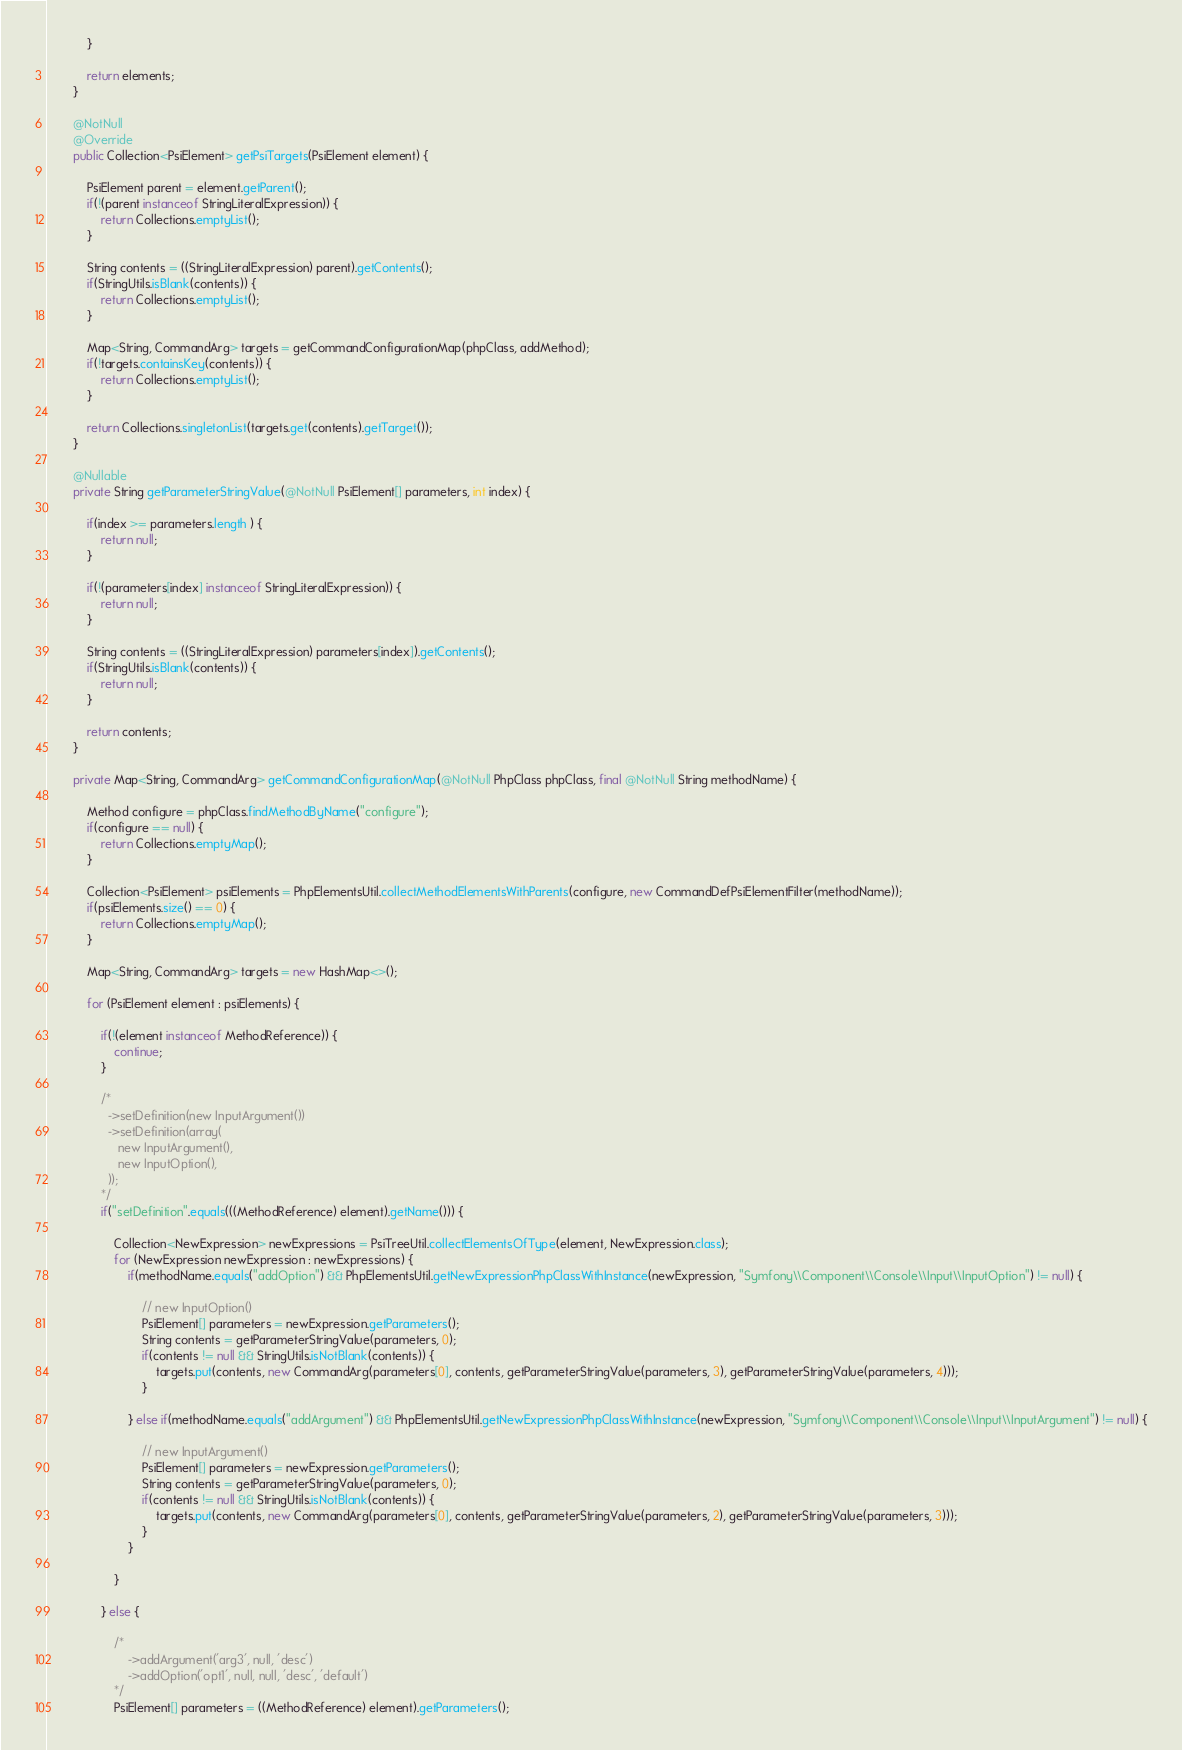<code> <loc_0><loc_0><loc_500><loc_500><_Java_>            }

            return elements;
        }

        @NotNull
        @Override
        public Collection<PsiElement> getPsiTargets(PsiElement element) {

            PsiElement parent = element.getParent();
            if(!(parent instanceof StringLiteralExpression)) {
                return Collections.emptyList();
            }

            String contents = ((StringLiteralExpression) parent).getContents();
            if(StringUtils.isBlank(contents)) {
                return Collections.emptyList();
            }

            Map<String, CommandArg> targets = getCommandConfigurationMap(phpClass, addMethod);
            if(!targets.containsKey(contents)) {
                return Collections.emptyList();
            }

            return Collections.singletonList(targets.get(contents).getTarget());
        }

        @Nullable
        private String getParameterStringValue(@NotNull PsiElement[] parameters, int index) {

            if(index >= parameters.length ) {
                return null;
            }

            if(!(parameters[index] instanceof StringLiteralExpression)) {
                return null;
            }

            String contents = ((StringLiteralExpression) parameters[index]).getContents();
            if(StringUtils.isBlank(contents)) {
                return null;
            }

            return contents;
        }

        private Map<String, CommandArg> getCommandConfigurationMap(@NotNull PhpClass phpClass, final @NotNull String methodName) {

            Method configure = phpClass.findMethodByName("configure");
            if(configure == null) {
                return Collections.emptyMap();
            }

            Collection<PsiElement> psiElements = PhpElementsUtil.collectMethodElementsWithParents(configure, new CommandDefPsiElementFilter(methodName));
            if(psiElements.size() == 0) {
                return Collections.emptyMap();
            }

            Map<String, CommandArg> targets = new HashMap<>();

            for (PsiElement element : psiElements) {

                if(!(element instanceof MethodReference)) {
                    continue;
                }

                /*
                  ->setDefinition(new InputArgument())
                  ->setDefinition(array(
                     new InputArgument(),
                     new InputOption(),
                  ));
                */
                if("setDefinition".equals(((MethodReference) element).getName())) {

                    Collection<NewExpression> newExpressions = PsiTreeUtil.collectElementsOfType(element, NewExpression.class);
                    for (NewExpression newExpression : newExpressions) {
                        if(methodName.equals("addOption") && PhpElementsUtil.getNewExpressionPhpClassWithInstance(newExpression, "Symfony\\Component\\Console\\Input\\InputOption") != null) {

                            // new InputOption()
                            PsiElement[] parameters = newExpression.getParameters();
                            String contents = getParameterStringValue(parameters, 0);
                            if(contents != null && StringUtils.isNotBlank(contents)) {
                                targets.put(contents, new CommandArg(parameters[0], contents, getParameterStringValue(parameters, 3), getParameterStringValue(parameters, 4)));
                            }

                        } else if(methodName.equals("addArgument") && PhpElementsUtil.getNewExpressionPhpClassWithInstance(newExpression, "Symfony\\Component\\Console\\Input\\InputArgument") != null) {

                            // new InputArgument()
                            PsiElement[] parameters = newExpression.getParameters();
                            String contents = getParameterStringValue(parameters, 0);
                            if(contents != null && StringUtils.isNotBlank(contents)) {
                                targets.put(contents, new CommandArg(parameters[0], contents, getParameterStringValue(parameters, 2), getParameterStringValue(parameters, 3)));
                            }
                        }

                    }

                } else {

                    /*
                        ->addArgument('arg3', null, 'desc')
                        ->addOption('opt1', null, null, 'desc', 'default')
                    */
                    PsiElement[] parameters = ((MethodReference) element).getParameters();</code> 